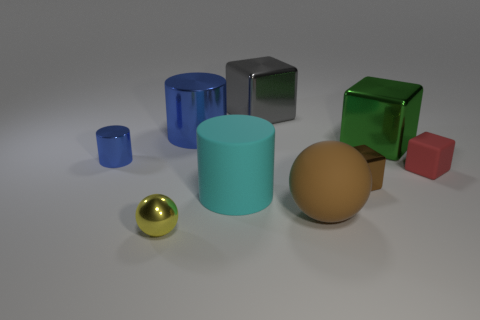Subtract all metal blocks. How many blocks are left? 1 Subtract all yellow cubes. Subtract all brown cylinders. How many cubes are left? 4 Subtract all spheres. How many objects are left? 7 Add 1 yellow shiny balls. How many yellow shiny balls are left? 2 Add 1 tiny shiny blocks. How many tiny shiny blocks exist? 2 Subtract 0 purple cylinders. How many objects are left? 9 Subtract all tiny green matte cylinders. Subtract all tiny metallic spheres. How many objects are left? 8 